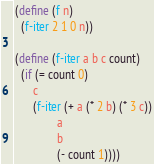Convert code to text. <code><loc_0><loc_0><loc_500><loc_500><_Scheme_>(define (f n)
  (f-iter 2 1 0 n))

(define (f-iter a b c count)
  (if (= count 0)
      c
      (f-iter (+ a (* 2 b) (* 3 c))
              a
              b
              (- count 1))))</code> 